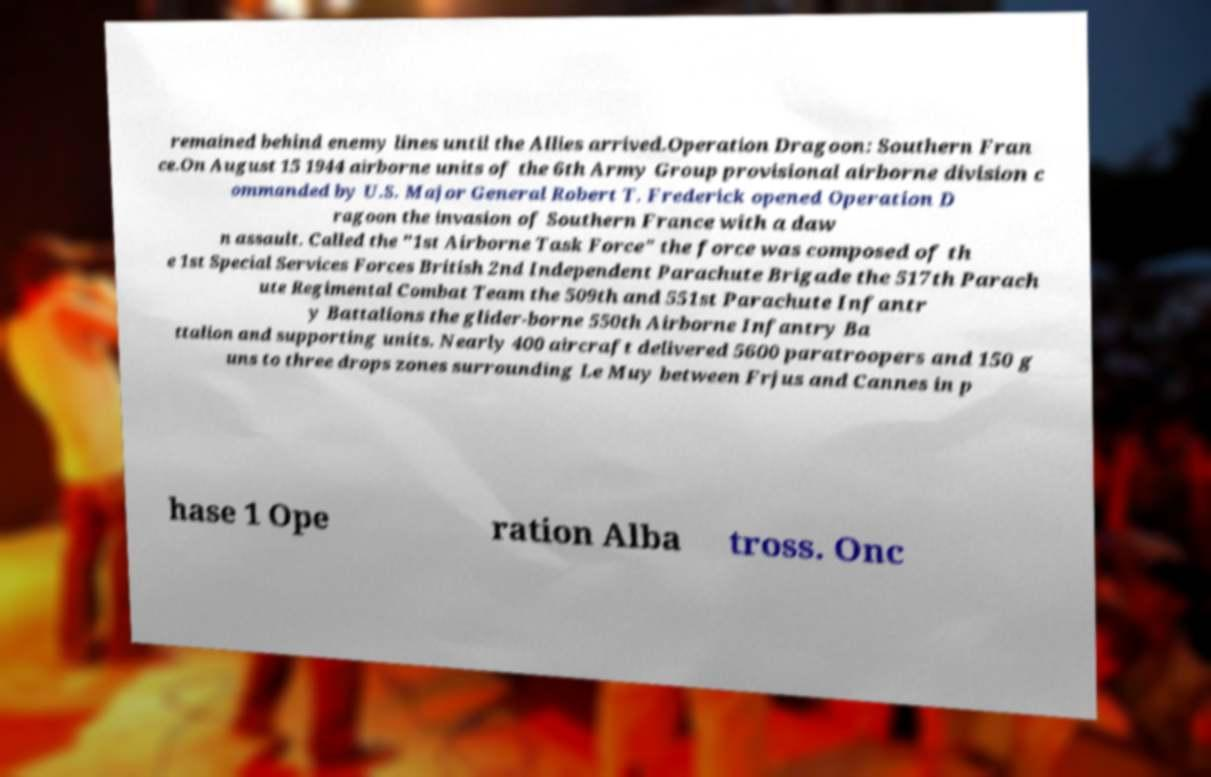What messages or text are displayed in this image? I need them in a readable, typed format. remained behind enemy lines until the Allies arrived.Operation Dragoon: Southern Fran ce.On August 15 1944 airborne units of the 6th Army Group provisional airborne division c ommanded by U.S. Major General Robert T. Frederick opened Operation D ragoon the invasion of Southern France with a daw n assault. Called the "1st Airborne Task Force" the force was composed of th e 1st Special Services Forces British 2nd Independent Parachute Brigade the 517th Parach ute Regimental Combat Team the 509th and 551st Parachute Infantr y Battalions the glider-borne 550th Airborne Infantry Ba ttalion and supporting units. Nearly 400 aircraft delivered 5600 paratroopers and 150 g uns to three drops zones surrounding Le Muy between Frjus and Cannes in p hase 1 Ope ration Alba tross. Onc 